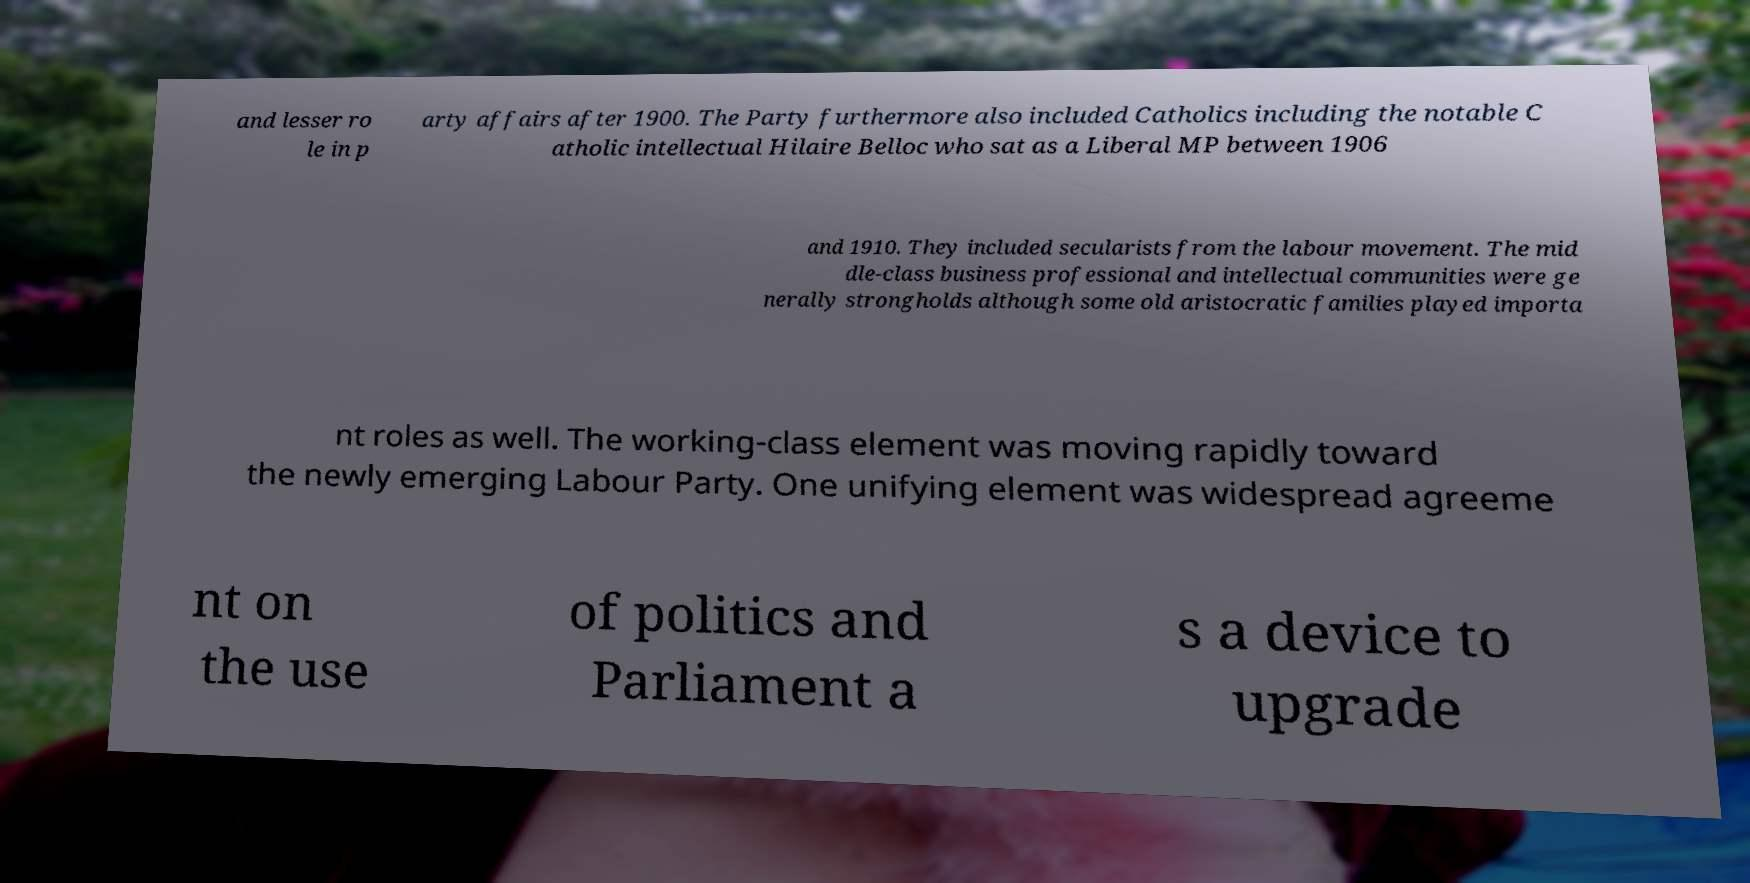Could you assist in decoding the text presented in this image and type it out clearly? and lesser ro le in p arty affairs after 1900. The Party furthermore also included Catholics including the notable C atholic intellectual Hilaire Belloc who sat as a Liberal MP between 1906 and 1910. They included secularists from the labour movement. The mid dle-class business professional and intellectual communities were ge nerally strongholds although some old aristocratic families played importa nt roles as well. The working-class element was moving rapidly toward the newly emerging Labour Party. One unifying element was widespread agreeme nt on the use of politics and Parliament a s a device to upgrade 